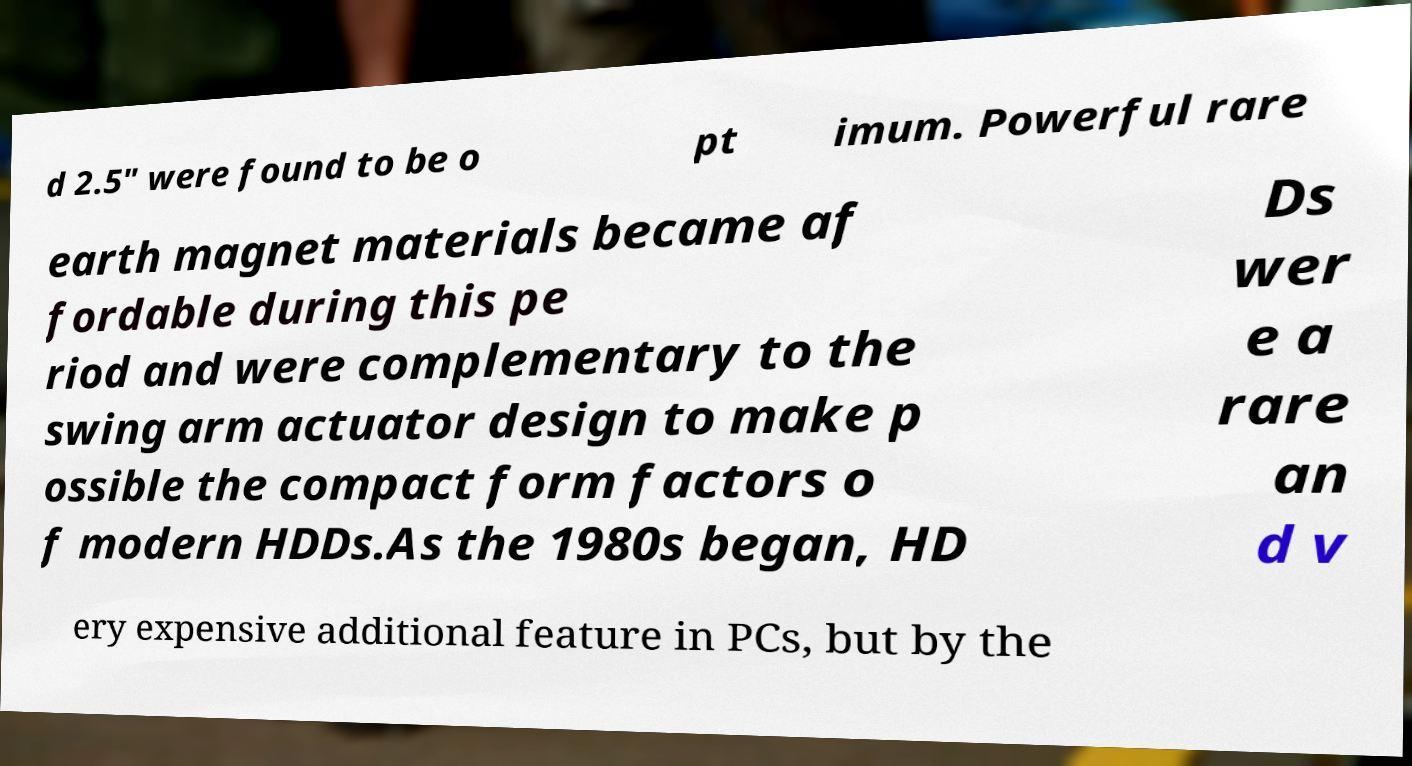Can you read and provide the text displayed in the image?This photo seems to have some interesting text. Can you extract and type it out for me? d 2.5" were found to be o pt imum. Powerful rare earth magnet materials became af fordable during this pe riod and were complementary to the swing arm actuator design to make p ossible the compact form factors o f modern HDDs.As the 1980s began, HD Ds wer e a rare an d v ery expensive additional feature in PCs, but by the 